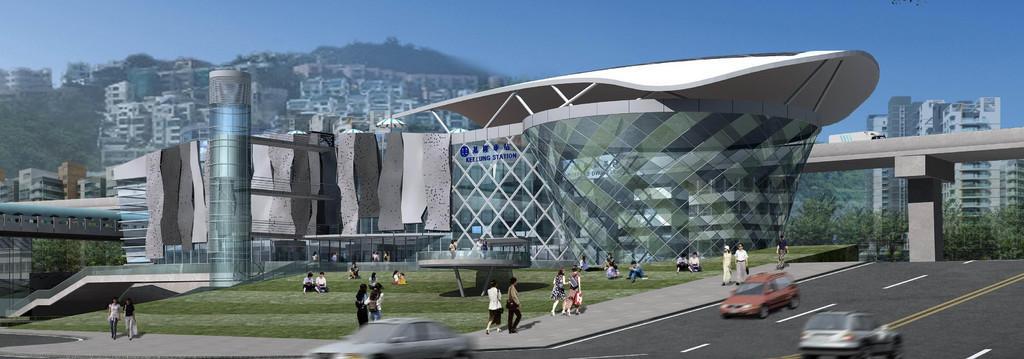Describe this image in one or two sentences. It looks like an edited image there is a road at the bottom. There are vehicles, people, grass and buildings in the foreground. There is a bridge, there are trees and buildings on the right corner. There are buildings and trees in the background. And there is sky at the top. 